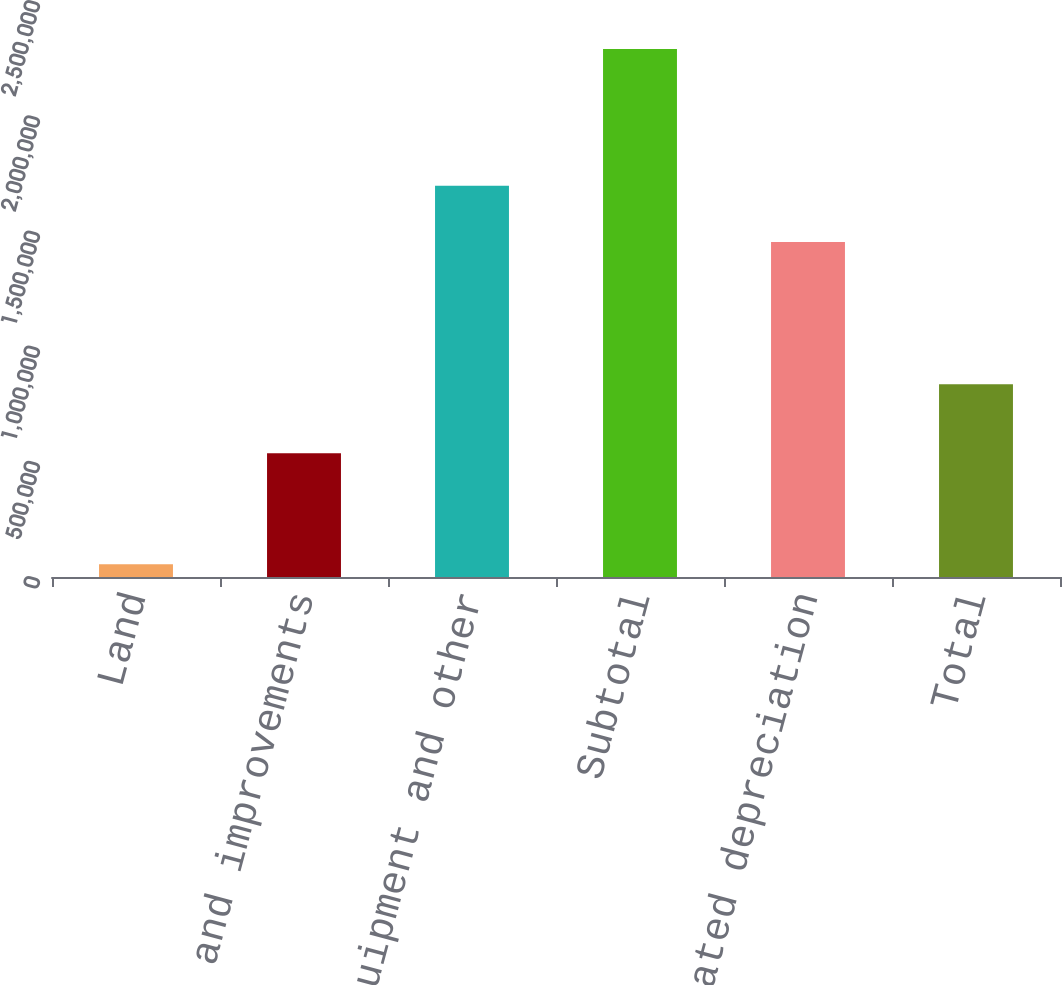Convert chart to OTSL. <chart><loc_0><loc_0><loc_500><loc_500><bar_chart><fcel>Land<fcel>Buildings and improvements<fcel>Machinery equipment and other<fcel>Subtotal<fcel>Less accumulated depreciation<fcel>Total<nl><fcel>55076<fcel>537474<fcel>1.69864e+06<fcel>2.29119e+06<fcel>1.45412e+06<fcel>837069<nl></chart> 